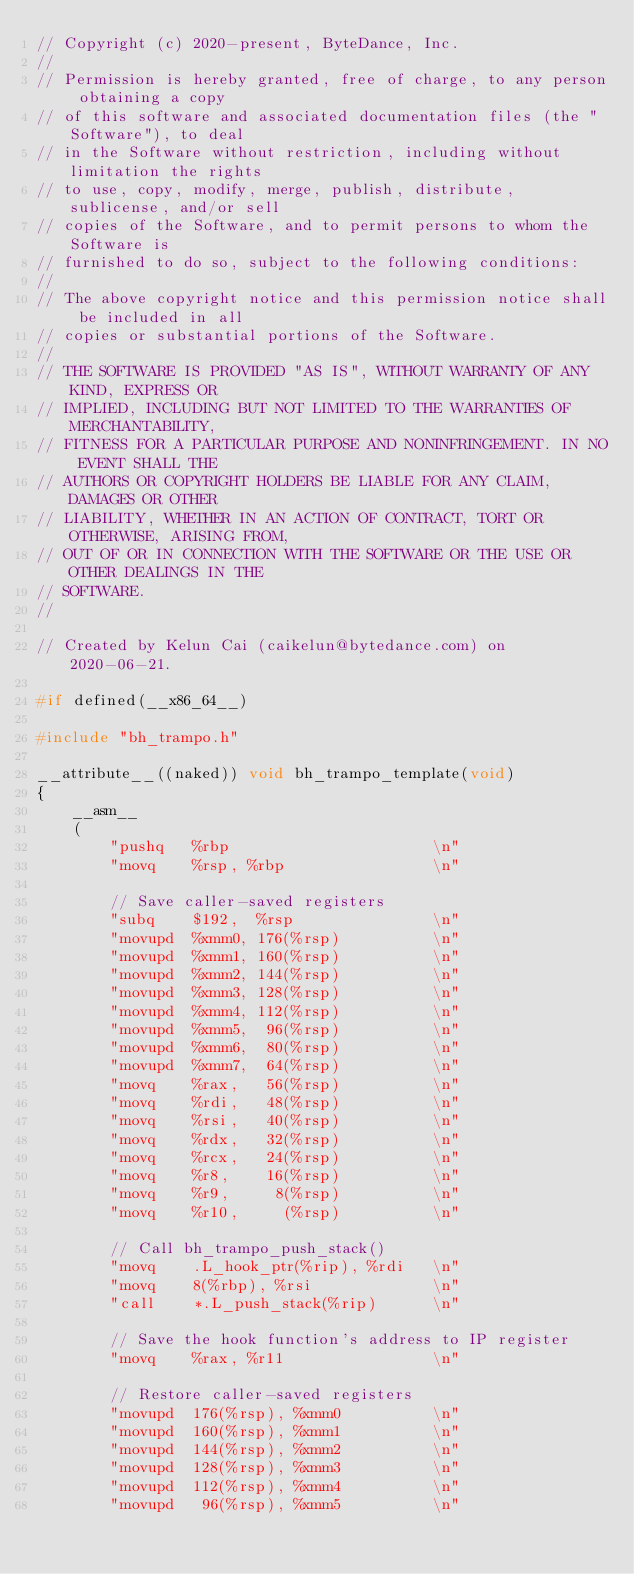<code> <loc_0><loc_0><loc_500><loc_500><_C_>// Copyright (c) 2020-present, ByteDance, Inc.
//
// Permission is hereby granted, free of charge, to any person obtaining a copy
// of this software and associated documentation files (the "Software"), to deal
// in the Software without restriction, including without limitation the rights
// to use, copy, modify, merge, publish, distribute, sublicense, and/or sell
// copies of the Software, and to permit persons to whom the Software is
// furnished to do so, subject to the following conditions:
//
// The above copyright notice and this permission notice shall be included in all
// copies or substantial portions of the Software.
//
// THE SOFTWARE IS PROVIDED "AS IS", WITHOUT WARRANTY OF ANY KIND, EXPRESS OR
// IMPLIED, INCLUDING BUT NOT LIMITED TO THE WARRANTIES OF MERCHANTABILITY,
// FITNESS FOR A PARTICULAR PURPOSE AND NONINFRINGEMENT. IN NO EVENT SHALL THE
// AUTHORS OR COPYRIGHT HOLDERS BE LIABLE FOR ANY CLAIM, DAMAGES OR OTHER
// LIABILITY, WHETHER IN AN ACTION OF CONTRACT, TORT OR OTHERWISE, ARISING FROM,
// OUT OF OR IN CONNECTION WITH THE SOFTWARE OR THE USE OR OTHER DEALINGS IN THE
// SOFTWARE.
//

// Created by Kelun Cai (caikelun@bytedance.com) on 2020-06-21.

#if defined(__x86_64__)

#include "bh_trampo.h"

__attribute__((naked)) void bh_trampo_template(void)
{
    __asm__
    (
        "pushq   %rbp                      \n"
        "movq    %rsp, %rbp                \n"

        // Save caller-saved registers
        "subq    $192,  %rsp               \n"
        "movupd  %xmm0, 176(%rsp)          \n"
        "movupd  %xmm1, 160(%rsp)          \n"
        "movupd  %xmm2, 144(%rsp)          \n"
        "movupd  %xmm3, 128(%rsp)          \n"
        "movupd  %xmm4, 112(%rsp)          \n"
        "movupd  %xmm5,  96(%rsp)          \n"
        "movupd  %xmm6,  80(%rsp)          \n"
        "movupd  %xmm7,  64(%rsp)          \n"
        "movq    %rax,   56(%rsp)          \n"
        "movq    %rdi,   48(%rsp)          \n"
        "movq    %rsi,   40(%rsp)          \n"
        "movq    %rdx,   32(%rsp)          \n"
        "movq    %rcx,   24(%rsp)          \n"
        "movq    %r8,    16(%rsp)          \n"
        "movq    %r9,     8(%rsp)          \n"
        "movq    %r10,     (%rsp)          \n"

        // Call bh_trampo_push_stack()
        "movq    .L_hook_ptr(%rip), %rdi   \n"
        "movq    8(%rbp), %rsi             \n"
        "call    *.L_push_stack(%rip)      \n"

        // Save the hook function's address to IP register
        "movq    %rax, %r11                \n"

        // Restore caller-saved registers
        "movupd  176(%rsp), %xmm0          \n"
        "movupd  160(%rsp), %xmm1          \n"
        "movupd  144(%rsp), %xmm2          \n"
        "movupd  128(%rsp), %xmm3          \n"
        "movupd  112(%rsp), %xmm4          \n"
        "movupd   96(%rsp), %xmm5          \n"</code> 